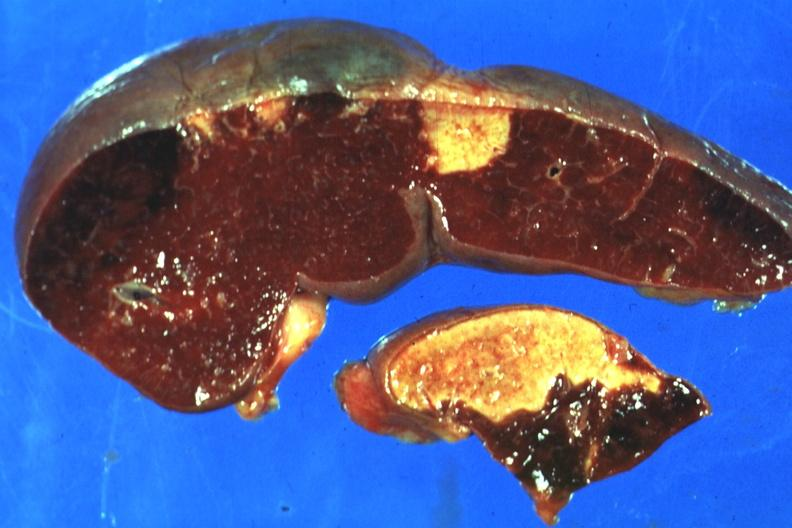does this image show excellent side with four infarcts shown which are several days of age from nonbacterial endocarditis?
Answer the question using a single word or phrase. Yes 